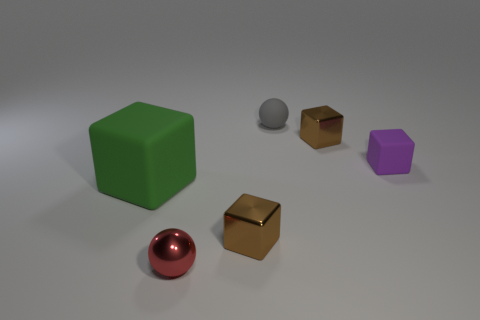What number of other objects are the same size as the gray rubber thing? Upon reviewing the image, there appears to be one object, a small golden cube, that is approximately the same size as the gray rubber sphere. 